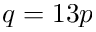Convert formula to latex. <formula><loc_0><loc_0><loc_500><loc_500>q = 1 3 p</formula> 